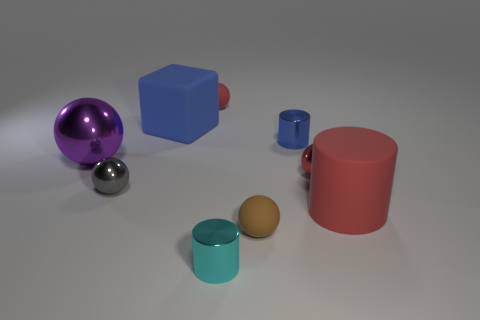Is the number of big red matte things right of the big cylinder less than the number of things?
Keep it short and to the point. Yes. There is a small red object that is to the left of the tiny cyan metal object that is left of the small blue thing; what is its shape?
Offer a terse response. Sphere. The big block is what color?
Give a very brief answer. Blue. How many other things are the same size as the brown ball?
Your answer should be very brief. 5. There is a large thing that is on the left side of the big rubber cylinder and on the right side of the large purple object; what is it made of?
Your answer should be very brief. Rubber. There is a red sphere on the left side of the blue metal object; is it the same size as the small cyan shiny thing?
Your answer should be very brief. Yes. Is the color of the big rubber cube the same as the big cylinder?
Your response must be concise. No. What number of metallic objects are on the left side of the cyan thing and on the right side of the large ball?
Give a very brief answer. 1. How many big blue objects are in front of the matte sphere behind the small matte object that is right of the tiny cyan metal cylinder?
Offer a very short reply. 1. There is a rubber sphere that is the same color as the large rubber cylinder; what is its size?
Your answer should be compact. Small. 